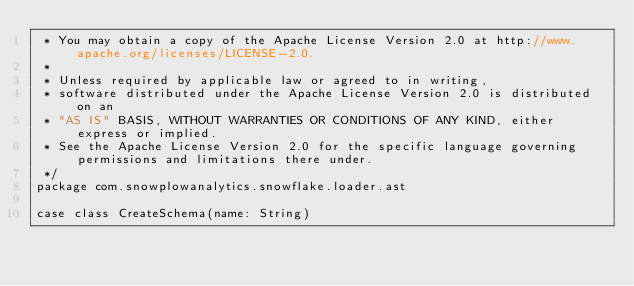Convert code to text. <code><loc_0><loc_0><loc_500><loc_500><_Scala_> * You may obtain a copy of the Apache License Version 2.0 at http://www.apache.org/licenses/LICENSE-2.0.
 *
 * Unless required by applicable law or agreed to in writing,
 * software distributed under the Apache License Version 2.0 is distributed on an
 * "AS IS" BASIS, WITHOUT WARRANTIES OR CONDITIONS OF ANY KIND, either express or implied.
 * See the Apache License Version 2.0 for the specific language governing permissions and limitations there under.
 */
package com.snowplowanalytics.snowflake.loader.ast

case class CreateSchema(name: String)
</code> 